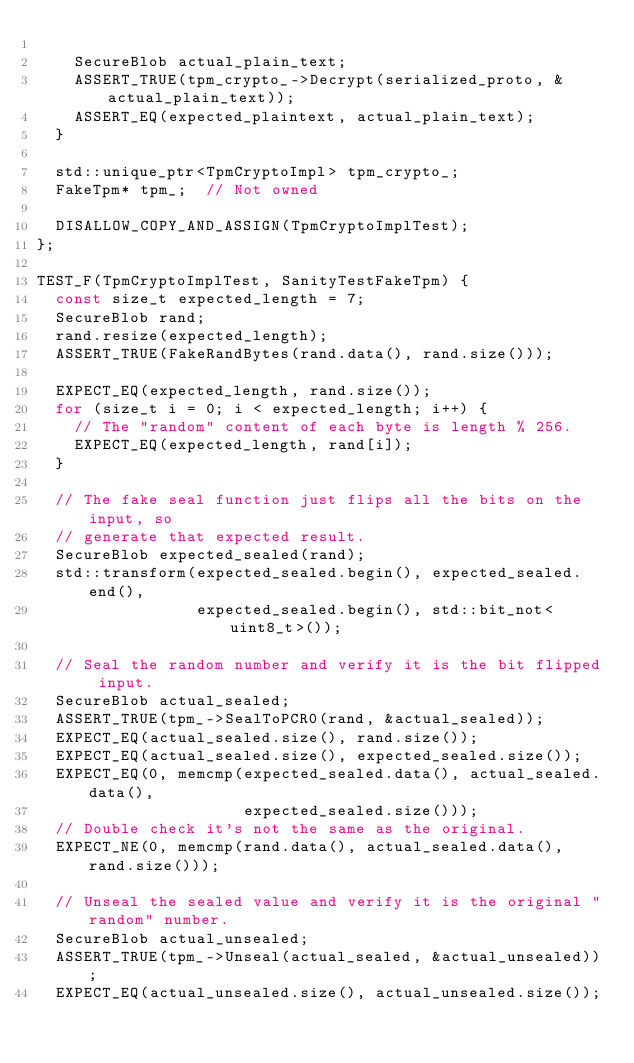<code> <loc_0><loc_0><loc_500><loc_500><_C++_>
    SecureBlob actual_plain_text;
    ASSERT_TRUE(tpm_crypto_->Decrypt(serialized_proto, &actual_plain_text));
    ASSERT_EQ(expected_plaintext, actual_plain_text);
  }

  std::unique_ptr<TpmCryptoImpl> tpm_crypto_;
  FakeTpm* tpm_;  // Not owned

  DISALLOW_COPY_AND_ASSIGN(TpmCryptoImplTest);
};

TEST_F(TpmCryptoImplTest, SanityTestFakeTpm) {
  const size_t expected_length = 7;
  SecureBlob rand;
  rand.resize(expected_length);
  ASSERT_TRUE(FakeRandBytes(rand.data(), rand.size()));

  EXPECT_EQ(expected_length, rand.size());
  for (size_t i = 0; i < expected_length; i++) {
    // The "random" content of each byte is length % 256.
    EXPECT_EQ(expected_length, rand[i]);
  }

  // The fake seal function just flips all the bits on the input, so
  // generate that expected result.
  SecureBlob expected_sealed(rand);
  std::transform(expected_sealed.begin(), expected_sealed.end(),
                 expected_sealed.begin(), std::bit_not<uint8_t>());

  // Seal the random number and verify it is the bit flipped input.
  SecureBlob actual_sealed;
  ASSERT_TRUE(tpm_->SealToPCR0(rand, &actual_sealed));
  EXPECT_EQ(actual_sealed.size(), rand.size());
  EXPECT_EQ(actual_sealed.size(), expected_sealed.size());
  EXPECT_EQ(0, memcmp(expected_sealed.data(), actual_sealed.data(),
                      expected_sealed.size()));
  // Double check it's not the same as the original.
  EXPECT_NE(0, memcmp(rand.data(), actual_sealed.data(), rand.size()));

  // Unseal the sealed value and verify it is the original "random" number.
  SecureBlob actual_unsealed;
  ASSERT_TRUE(tpm_->Unseal(actual_sealed, &actual_unsealed));
  EXPECT_EQ(actual_unsealed.size(), actual_unsealed.size());</code> 